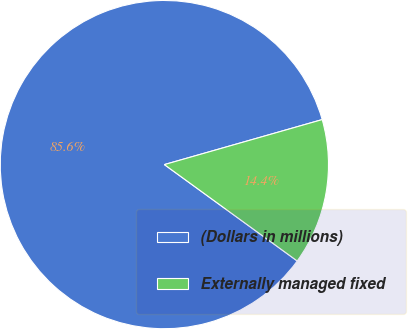<chart> <loc_0><loc_0><loc_500><loc_500><pie_chart><fcel>(Dollars in millions)<fcel>Externally managed fixed<nl><fcel>85.59%<fcel>14.41%<nl></chart> 